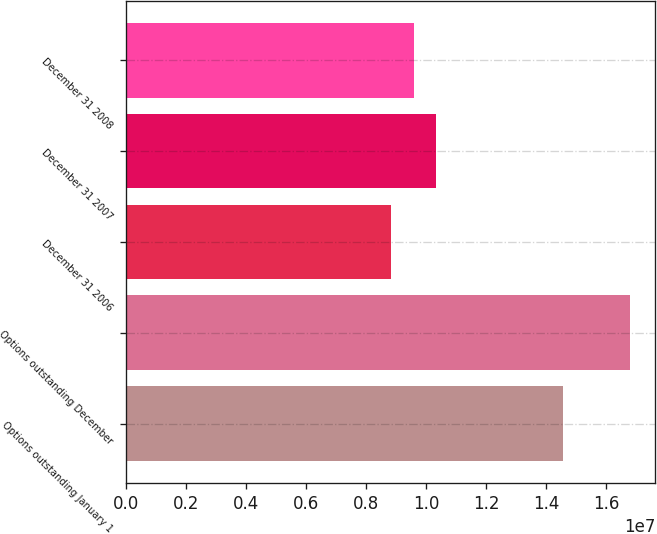Convert chart. <chart><loc_0><loc_0><loc_500><loc_500><bar_chart><fcel>Options outstanding January 1<fcel>Options outstanding December<fcel>December 31 2006<fcel>December 31 2007<fcel>December 31 2008<nl><fcel>1.45513e+07<fcel>1.67824e+07<fcel>8.82688e+06<fcel>1.03143e+07<fcel>9.57058e+06<nl></chart> 